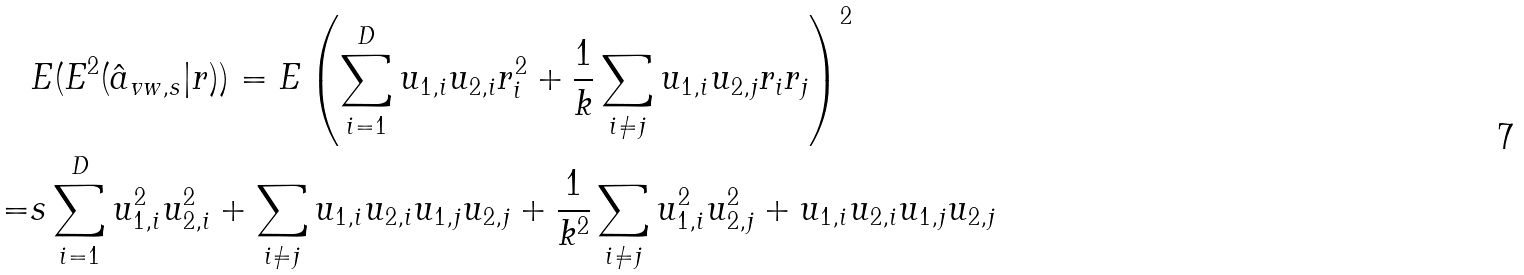Convert formula to latex. <formula><loc_0><loc_0><loc_500><loc_500>& E ( E ^ { 2 } ( \hat { a } _ { v w , s } | r ) ) = E \left ( \sum _ { i = 1 } ^ { D } u _ { 1 , i } u _ { 2 , i } r _ { i } ^ { 2 } + \frac { 1 } { k } \sum _ { i \neq j } u _ { 1 , i } u _ { 2 , j } r _ { i } r _ { j } \right ) ^ { 2 } \\ = & s \sum _ { i = 1 } ^ { D } u _ { 1 , i } ^ { 2 } u _ { 2 , i } ^ { 2 } + \sum _ { i \neq j } u _ { 1 , i } u _ { 2 , i } u _ { 1 , j } u _ { 2 , j } + \frac { 1 } { k ^ { 2 } } \sum _ { i \neq j } u _ { 1 , i } ^ { 2 } u _ { 2 , j } ^ { 2 } + u _ { 1 , i } u _ { 2 , i } u _ { 1 , j } u _ { 2 , j }</formula> 